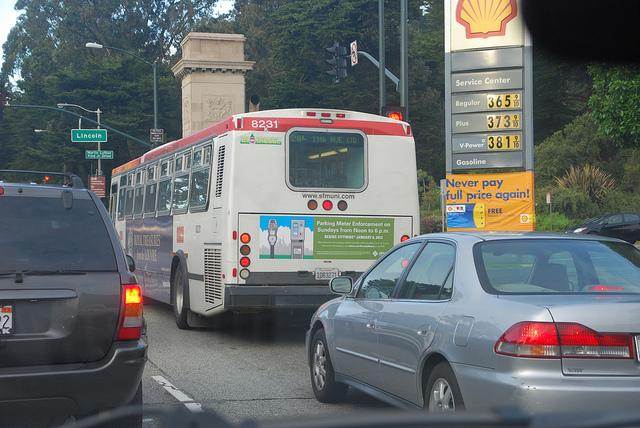What does the business sell?

Choices:
A) animals
B) books
C) gas
D) electronics gas 